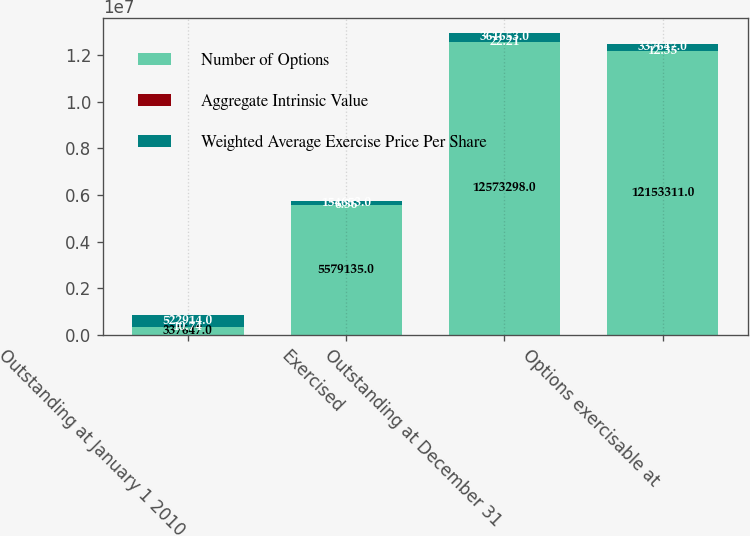<chart> <loc_0><loc_0><loc_500><loc_500><stacked_bar_chart><ecel><fcel>Outstanding at January 1 2010<fcel>Exercised<fcel>Outstanding at December 31<fcel>Options exercisable at<nl><fcel>Number of Options<fcel>337647<fcel>5.57914e+06<fcel>1.25733e+07<fcel>1.21533e+07<nl><fcel>Aggregate Intrinsic Value<fcel>10.74<fcel>6.36<fcel>22.21<fcel>12.35<nl><fcel>Weighted Average Exercise Price Per Share<fcel>522914<fcel>154653<fcel>361653<fcel>337647<nl></chart> 